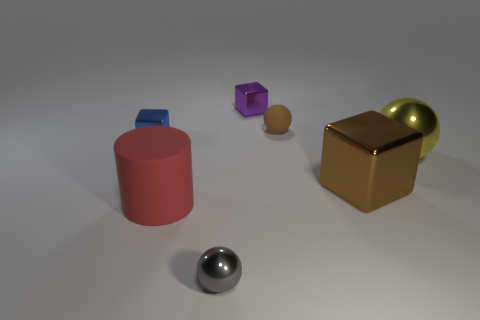Are there any other things that have the same shape as the large red thing?
Make the answer very short. No. Are there any large red shiny objects?
Offer a terse response. No. Do the ball that is in front of the red rubber cylinder and the cube in front of the small blue metal thing have the same material?
Your answer should be compact. Yes. There is a block that is behind the tiny sphere that is behind the metallic ball on the left side of the yellow metal thing; how big is it?
Offer a terse response. Small. What number of big yellow balls have the same material as the blue object?
Make the answer very short. 1. Is the number of rubber spheres less than the number of purple rubber balls?
Your answer should be very brief. No. The other shiny thing that is the same shape as the small gray object is what size?
Your answer should be compact. Large. Is the material of the cube that is in front of the big sphere the same as the blue cube?
Make the answer very short. Yes. Do the purple metal thing and the yellow metal thing have the same shape?
Your answer should be compact. No. What number of things are either tiny blue things to the left of the large metal ball or large brown cylinders?
Your answer should be compact. 1. 